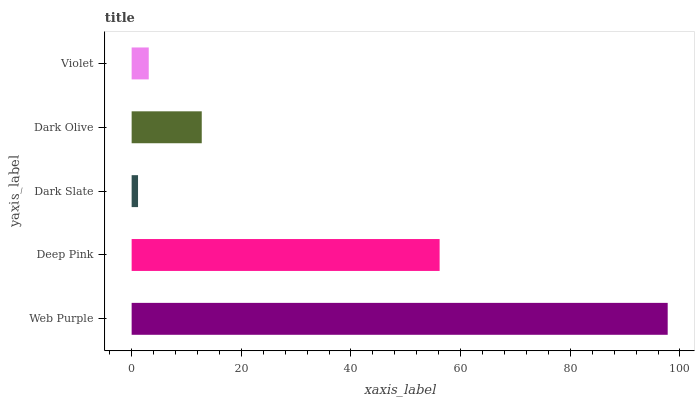Is Dark Slate the minimum?
Answer yes or no. Yes. Is Web Purple the maximum?
Answer yes or no. Yes. Is Deep Pink the minimum?
Answer yes or no. No. Is Deep Pink the maximum?
Answer yes or no. No. Is Web Purple greater than Deep Pink?
Answer yes or no. Yes. Is Deep Pink less than Web Purple?
Answer yes or no. Yes. Is Deep Pink greater than Web Purple?
Answer yes or no. No. Is Web Purple less than Deep Pink?
Answer yes or no. No. Is Dark Olive the high median?
Answer yes or no. Yes. Is Dark Olive the low median?
Answer yes or no. Yes. Is Deep Pink the high median?
Answer yes or no. No. Is Deep Pink the low median?
Answer yes or no. No. 